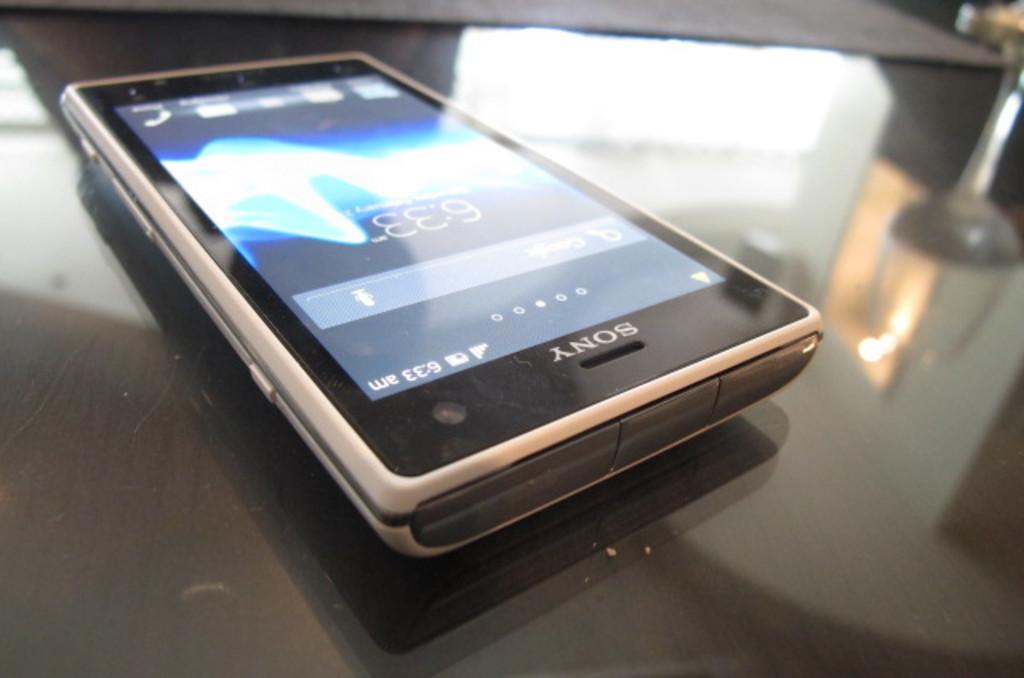<image>
Write a terse but informative summary of the picture. A Sony cell phone that is displaying 6:33 as the time. 